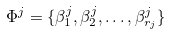Convert formula to latex. <formula><loc_0><loc_0><loc_500><loc_500>\Phi ^ { j } = \{ \beta ^ { j } _ { 1 } , \beta ^ { j } _ { 2 } , \dots , \beta ^ { j } _ { r _ { j } } \}</formula> 